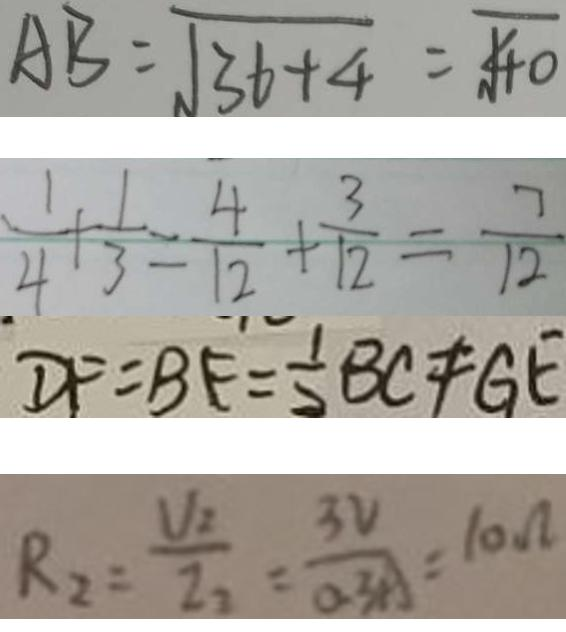<formula> <loc_0><loc_0><loc_500><loc_500>A B = \sqrt { 3 6 + 4 } = \sqrt { 4 0 } 
 \frac { 1 } { 4 } + \frac { 1 } { 3 } = \frac { 4 } { 1 2 } + \frac { 3 } { 1 2 } = \frac { 7 } { 1 2 } 
 D F = B F = \frac { 1 } { 2 } B C \neq G E 
 R _ { 2 } = \frac { V _ { 2 } } { I _ { 2 } } = \frac { 3 V } { 0 . 3 A } = 1 0 \Omega</formula> 